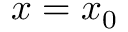<formula> <loc_0><loc_0><loc_500><loc_500>x = x _ { 0 }</formula> 